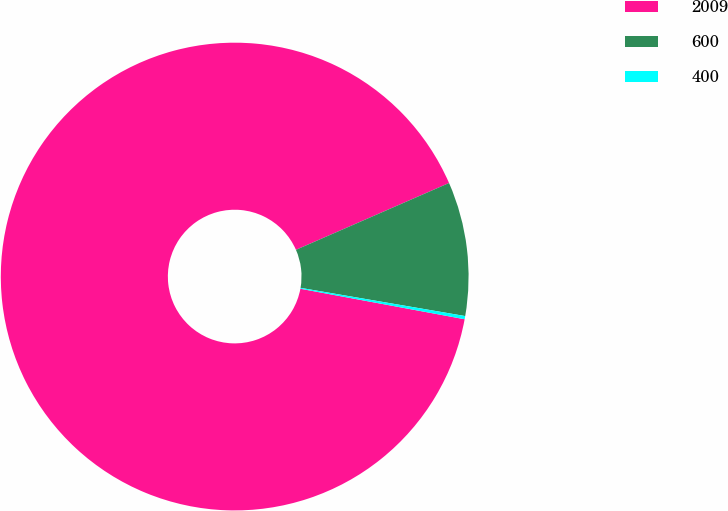<chart> <loc_0><loc_0><loc_500><loc_500><pie_chart><fcel>2009<fcel>600<fcel>400<nl><fcel>90.53%<fcel>9.25%<fcel>0.22%<nl></chart> 